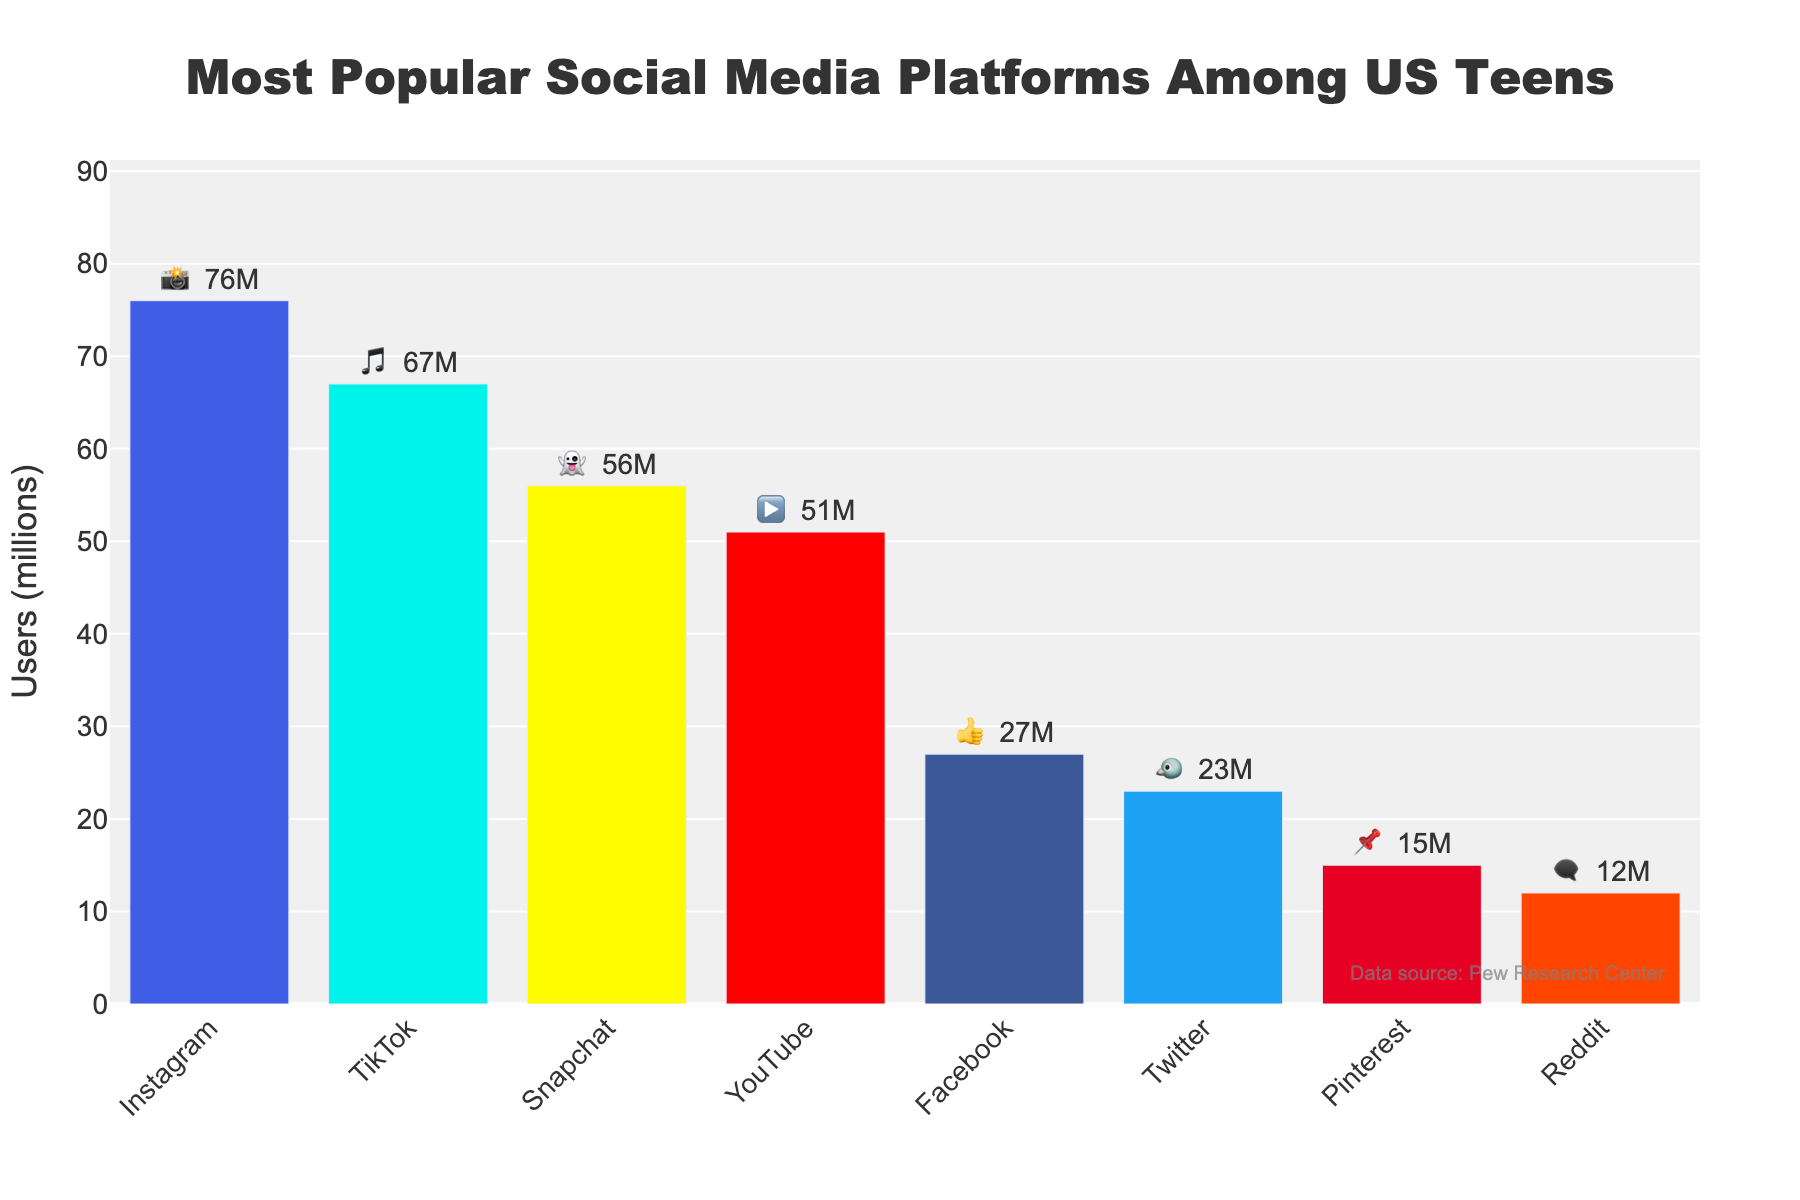what is the title of the chart? The title appears at the top of the chart and usually describes the content of the chart. In this case, it reads "Most Popular Social Media Platforms Among US Teens".
Answer: Most Popular Social Media Platforms Among US Teens Which platform has the most users? Identify the tallest bar in the bar chart, which represents the platform with the highest number of users. The longest bar has 76 million users, indicated by the camera emoji 📸, representing Instagram.
Answer: Instagram What is the users' difference between TikTok and Facebook? Find the user counts for TikTok and Facebook, then subtract the lower user count (Facebook) from the higher one (TikTok). TikTok has 67 million users and Facebook has 27 million users, so 67 - 27 = 40 million.
Answer: 40 million How many platforms have fewer than 50 million users? Count the number of bars that represent platforms with user counts below 50 million. Platforms under this count are Facebook, Twitter, Pinterest, and Reddit, totaling to four.
Answer: 4 What's the second most popular platform among US teens? Identify the bar with the second highest number of users after the tallest bar. The second longest bar represents TikTok with 67 million users, denoted by the musical note emoji 🎵.
Answer: TikTok Which platforms have more users: Instagram and Snapchat combined or YouTube and Facebook combined? Sum the users for Instagram and Snapchat, then sum the users for YouTube and Facebook. Compare the two totals. Instagram + Snapchat = 76 + 56 = 132 million, YouTube + Facebook = 51 + 27 = 78 million. 132 million > 78 million.
Answer: Instagram and Snapchat combined What is the least popular platform among US teens? Look at the shortest bar on the chart, which represents the platform with the fewest users. The shortest bar indicates 12 million users, denoted by the speech bubble emoji 🗨️, representing Reddit.
Answer: Reddit What’s the total number of users for all the listed platforms combined? Add up the user numbers for all platforms. 76 (Instagram) + 67 (TikTok) + 56 (Snapchat) + 51 (YouTube) + 27 (Facebook) + 23 (Twitter) + 15 (Pinterest) + 12 (Reddit) = 327 million.
Answer: 327 million Which platform has the most visually distinctive color? Each bar is a different color, and visually distinctive would imply brightness or contrast. The bar representing TikTok is a bright and visually distinctive cyan color.
Answer: TikTok 